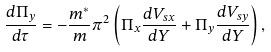Convert formula to latex. <formula><loc_0><loc_0><loc_500><loc_500>\frac { d \Pi _ { y } } { d \tau } = - \frac { m ^ { * } } { m } \pi ^ { 2 } \left ( \Pi _ { x } \frac { d V _ { s x } } { d Y } + \Pi _ { y } \frac { d V _ { s y } } { d Y } \right ) ,</formula> 